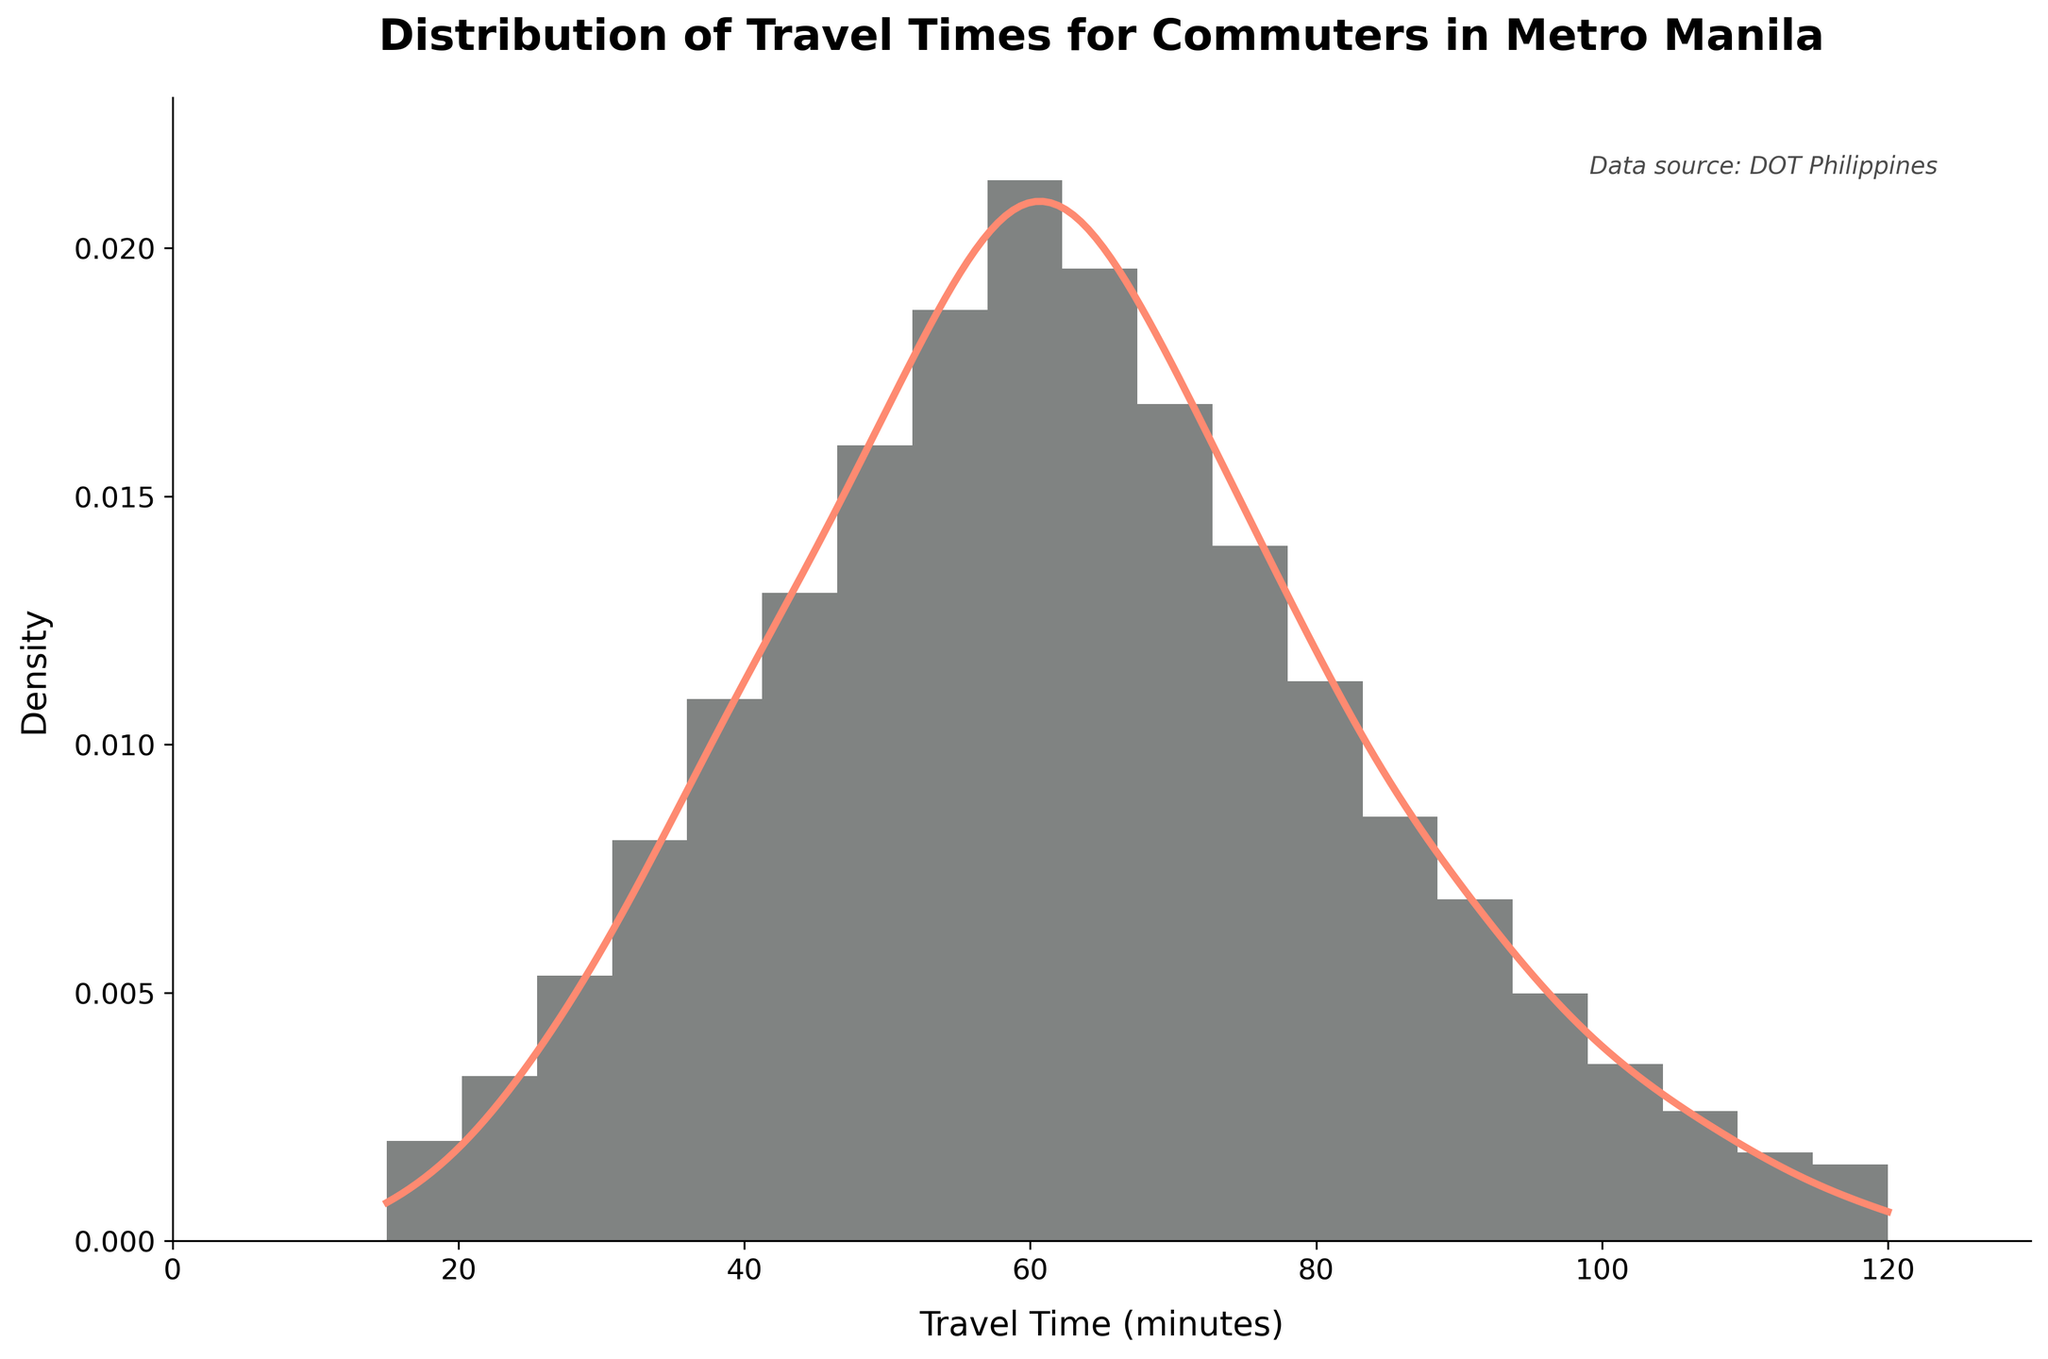What is the title of the plot? The title of the plot can be found on top of the figure. It describes what the figure is showing. The title reads "Distribution of Travel Times for Commuters in Metro Manila".
Answer: Distribution of Travel Times for Commuters in Metro Manila What is the peak travel time during rush hours? To determine the peak travel time, look for the highest point on the histogram and KDE curve. The highest density occurs around 60 minutes.
Answer: 60 minutes Which travel time interval has the least frequency? The bar indicating the least height would be the interval with the fewest occurrences. The intervals at 15 and 120 minutes both have the least frequency.
Answer: 15 and 120 minutes How many intervals are there on the x-axis? Counting the number of bars on the x-axis provides the total number of intervals. There are 20 intervals, as seen by the bins used in the histogram.
Answer: 20 Between 45 and 75 minutes, where does the KDE curve peak? Identify the highest point of the KDE curve between the 45 and 75-minute intervals. This peak occurs around 60 minutes.
Answer: 60 minutes Where does the histogram show the highest concentration of travel times? The highest concentration is where the histogram's tallest bars are located. This is around the 55-65 minute range.
Answer: 55-65 minutes What is the general trend of travel time frequency after 60 minutes? Look at the histogram and KDE curve after the peak at 60 minutes. Both the histogram and KDE curve show a decreasing trend after 60 minutes.
Answer: Decreasing How does the frequency of travel times at 40 minutes compare to 90 minutes? Compare the heights of the bars at 40 minutes and 90 minutes. The bar at 40 minutes is higher, meaning greater frequency than at 90 minutes.
Answer: 40 minutes has a higher frequency What does the text annotation on the plot indicate? The text annotation at the top right corner provides additional information about the data's origin. It indicates the data source is the DOT Philippines.
Answer: Data source: DOT Philippines What can you infer about congestion patterns from this distribution? The distribution shows the majority of travel times are centered around 60 minutes, indicating significant congestion during rush hours at this time. Lower frequencies at both shorter and longer travel times suggest fewer commuters experience these extremes.
Answer: Significant congestion is indicated around 60 minutes 